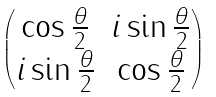<formula> <loc_0><loc_0><loc_500><loc_500>\begin{pmatrix} \cos { \frac { \theta } { 2 } } & i \sin { \frac { \theta } { 2 } } \\ i \sin { \frac { \theta } { 2 } } & \cos { \frac { \theta } { 2 } } \end{pmatrix}</formula> 